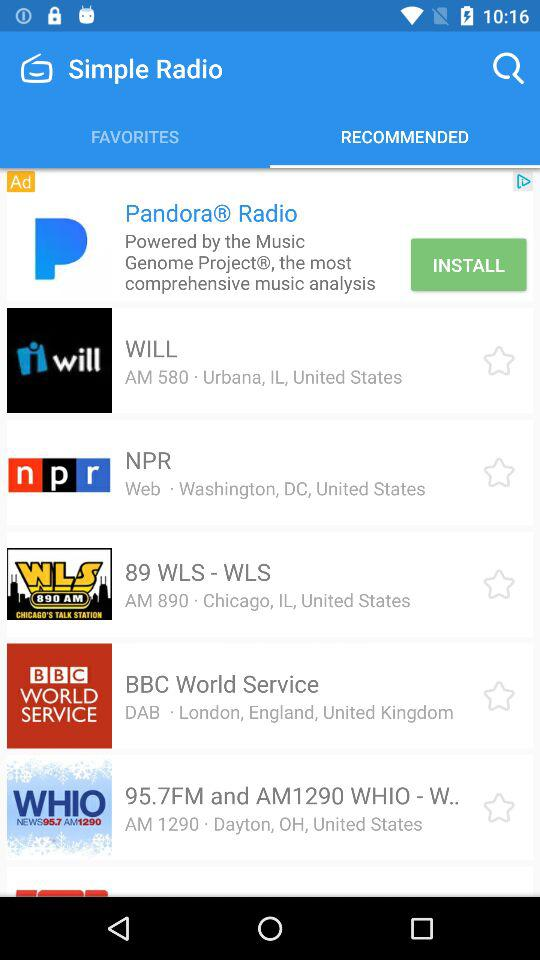What is the selected tab? The selected tab is "RECOMMENDED". 